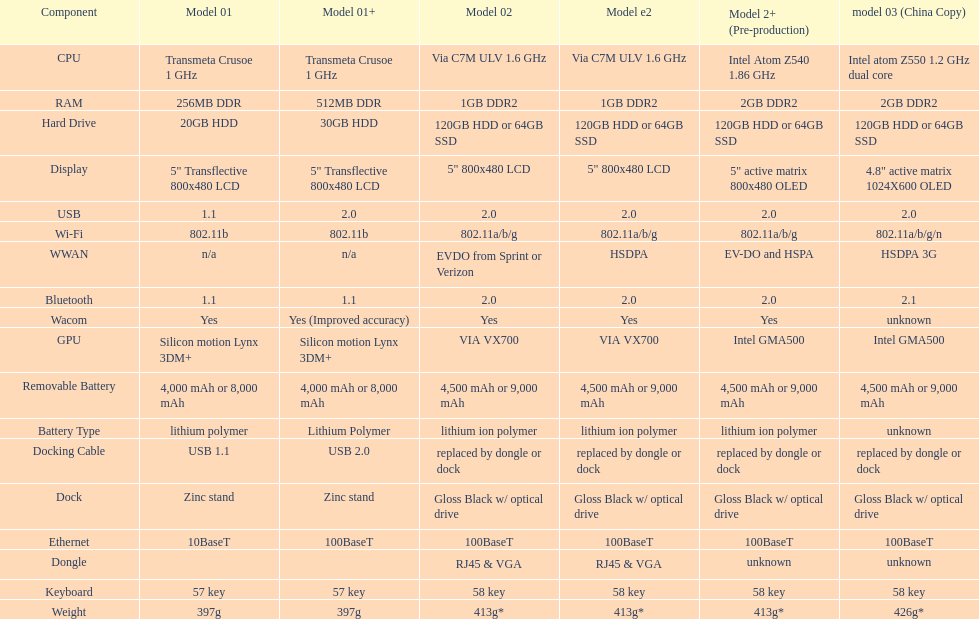After the 30gb hard drive, what is the subsequent larger storage option available? 64GB SSD. 